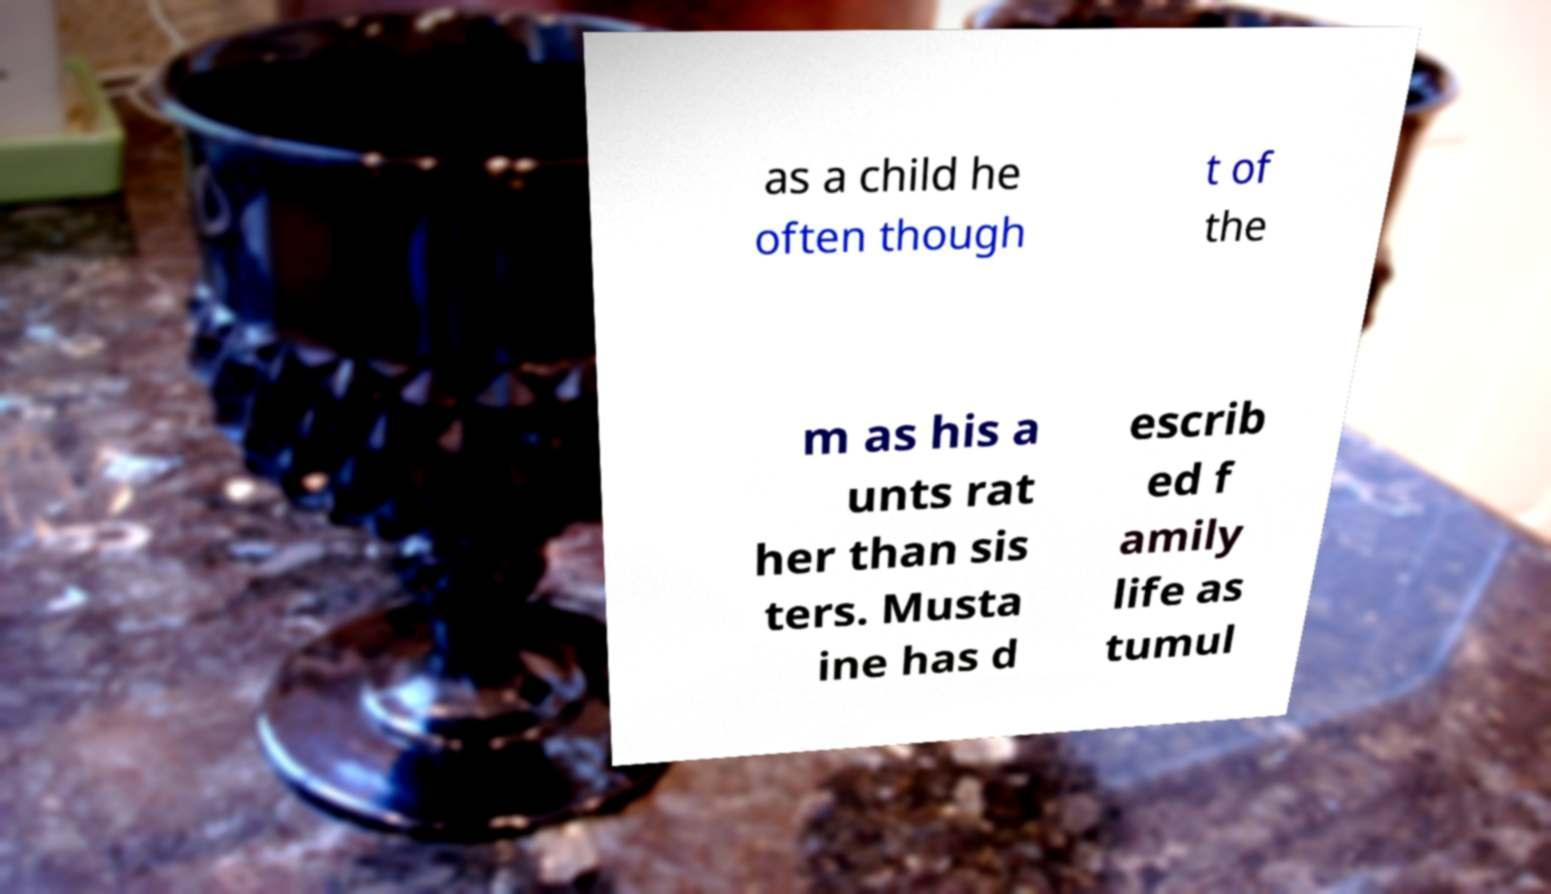There's text embedded in this image that I need extracted. Can you transcribe it verbatim? as a child he often though t of the m as his a unts rat her than sis ters. Musta ine has d escrib ed f amily life as tumul 